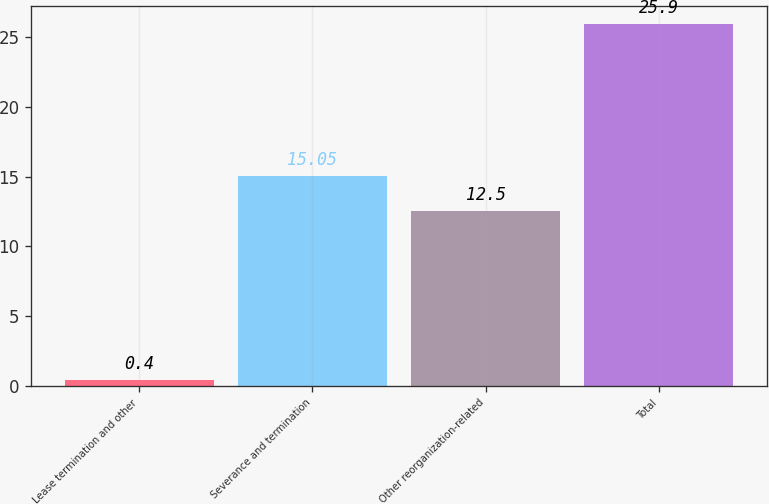<chart> <loc_0><loc_0><loc_500><loc_500><bar_chart><fcel>Lease termination and other<fcel>Severance and termination<fcel>Other reorganization-related<fcel>Total<nl><fcel>0.4<fcel>15.05<fcel>12.5<fcel>25.9<nl></chart> 